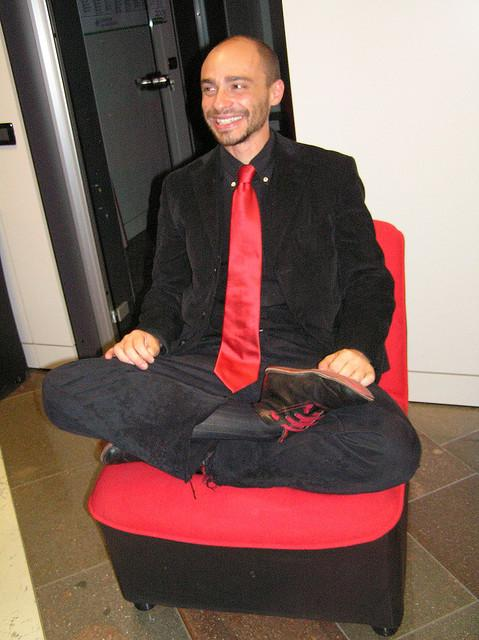What is the man wearing? Please explain your reasoning. tie. The man has a red tie around his neck. 